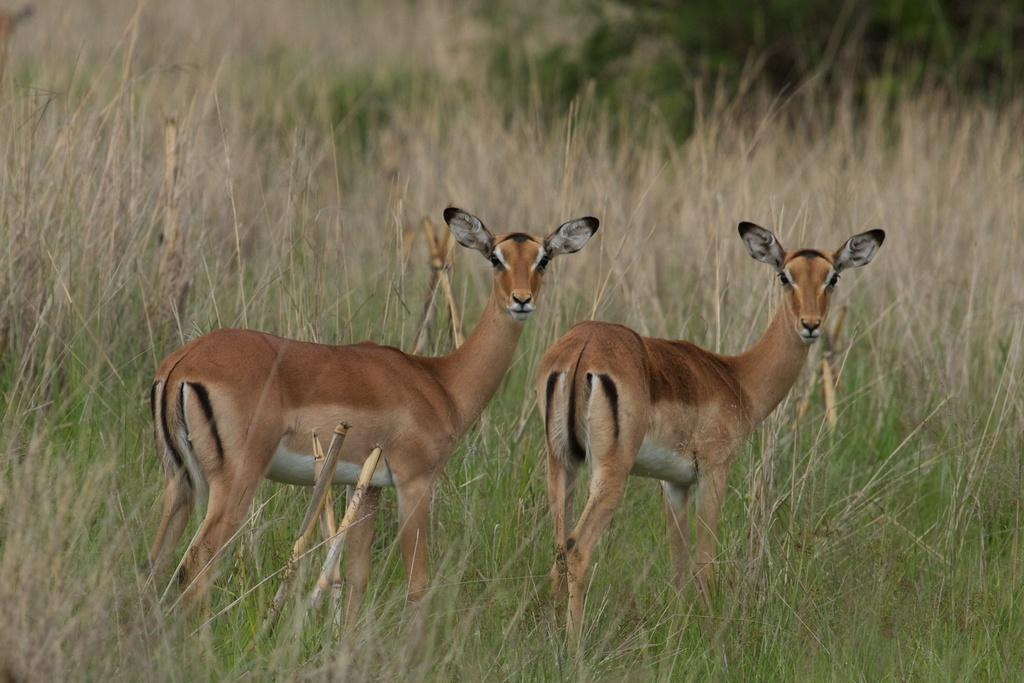What animal is present in the image? There is a gazelle in the image. What type of environment is visible in the background of the image? There is grass visible in the background of the image. What position does the pan hold in the image? There is no pan present in the image. What things are being held by the gazelle in the image? The provided facts do not mention any objects being held by the gazelle, so we cannot answer this question. 